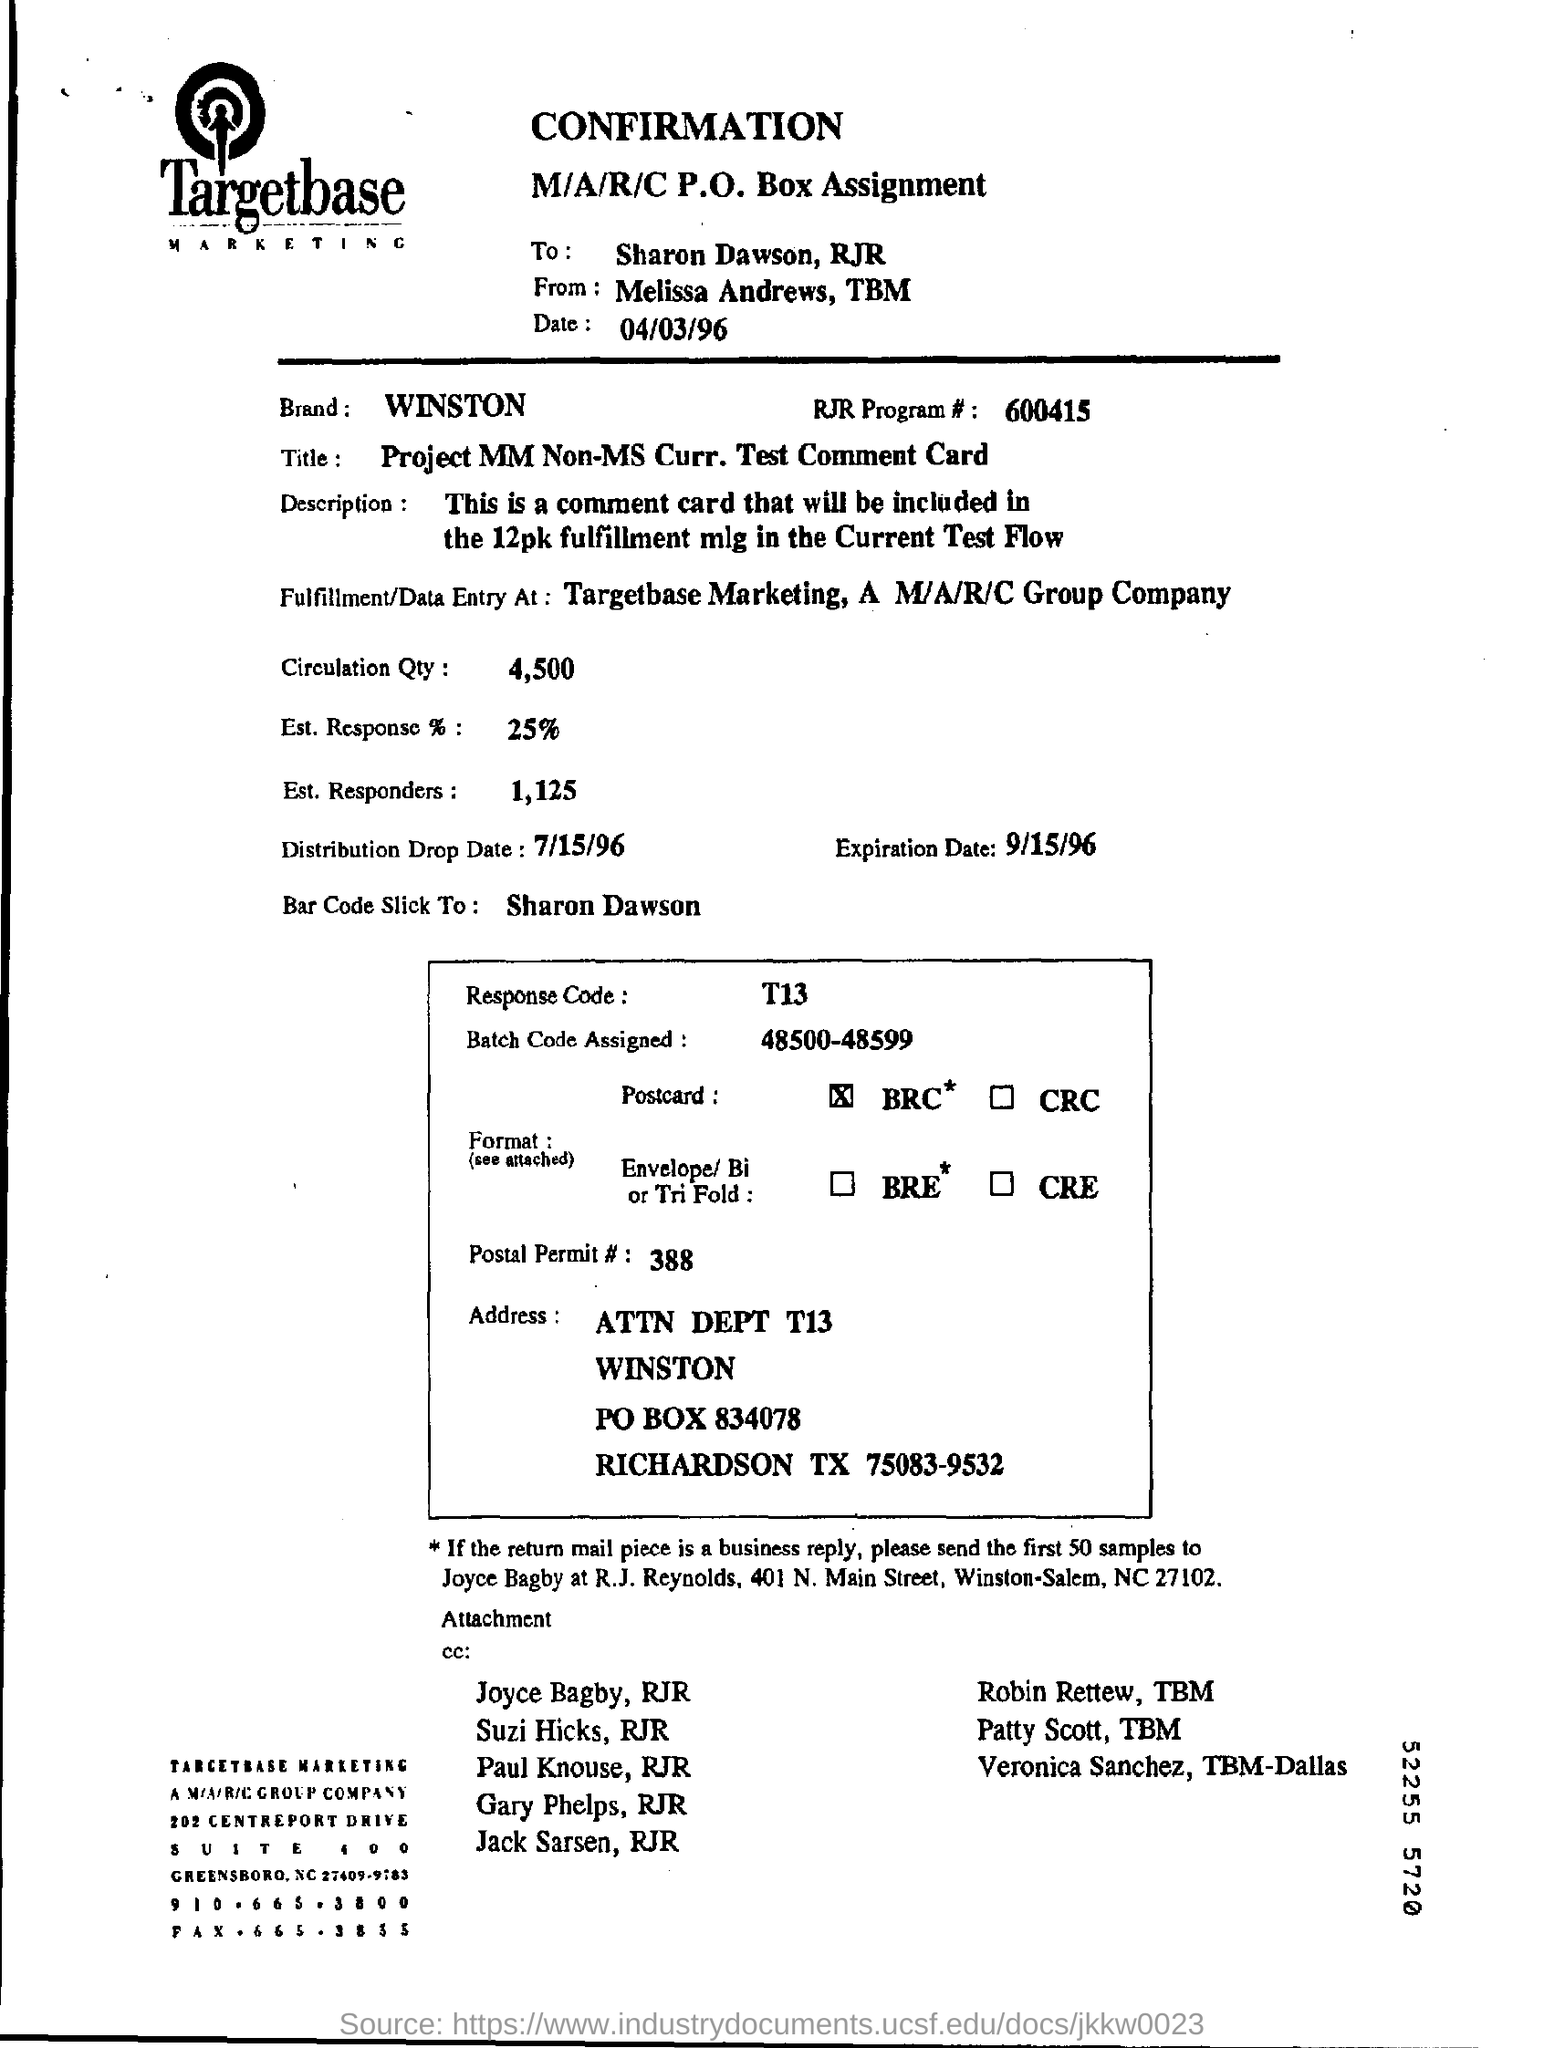What is the batch code assigned?
Your answer should be very brief. 4850048599. What is the postal permit?
Your answer should be very brief. 388. What is the response code?
Make the answer very short. T13. To whom bar code is slick to?
Ensure brevity in your answer.  Sharon dawson. 